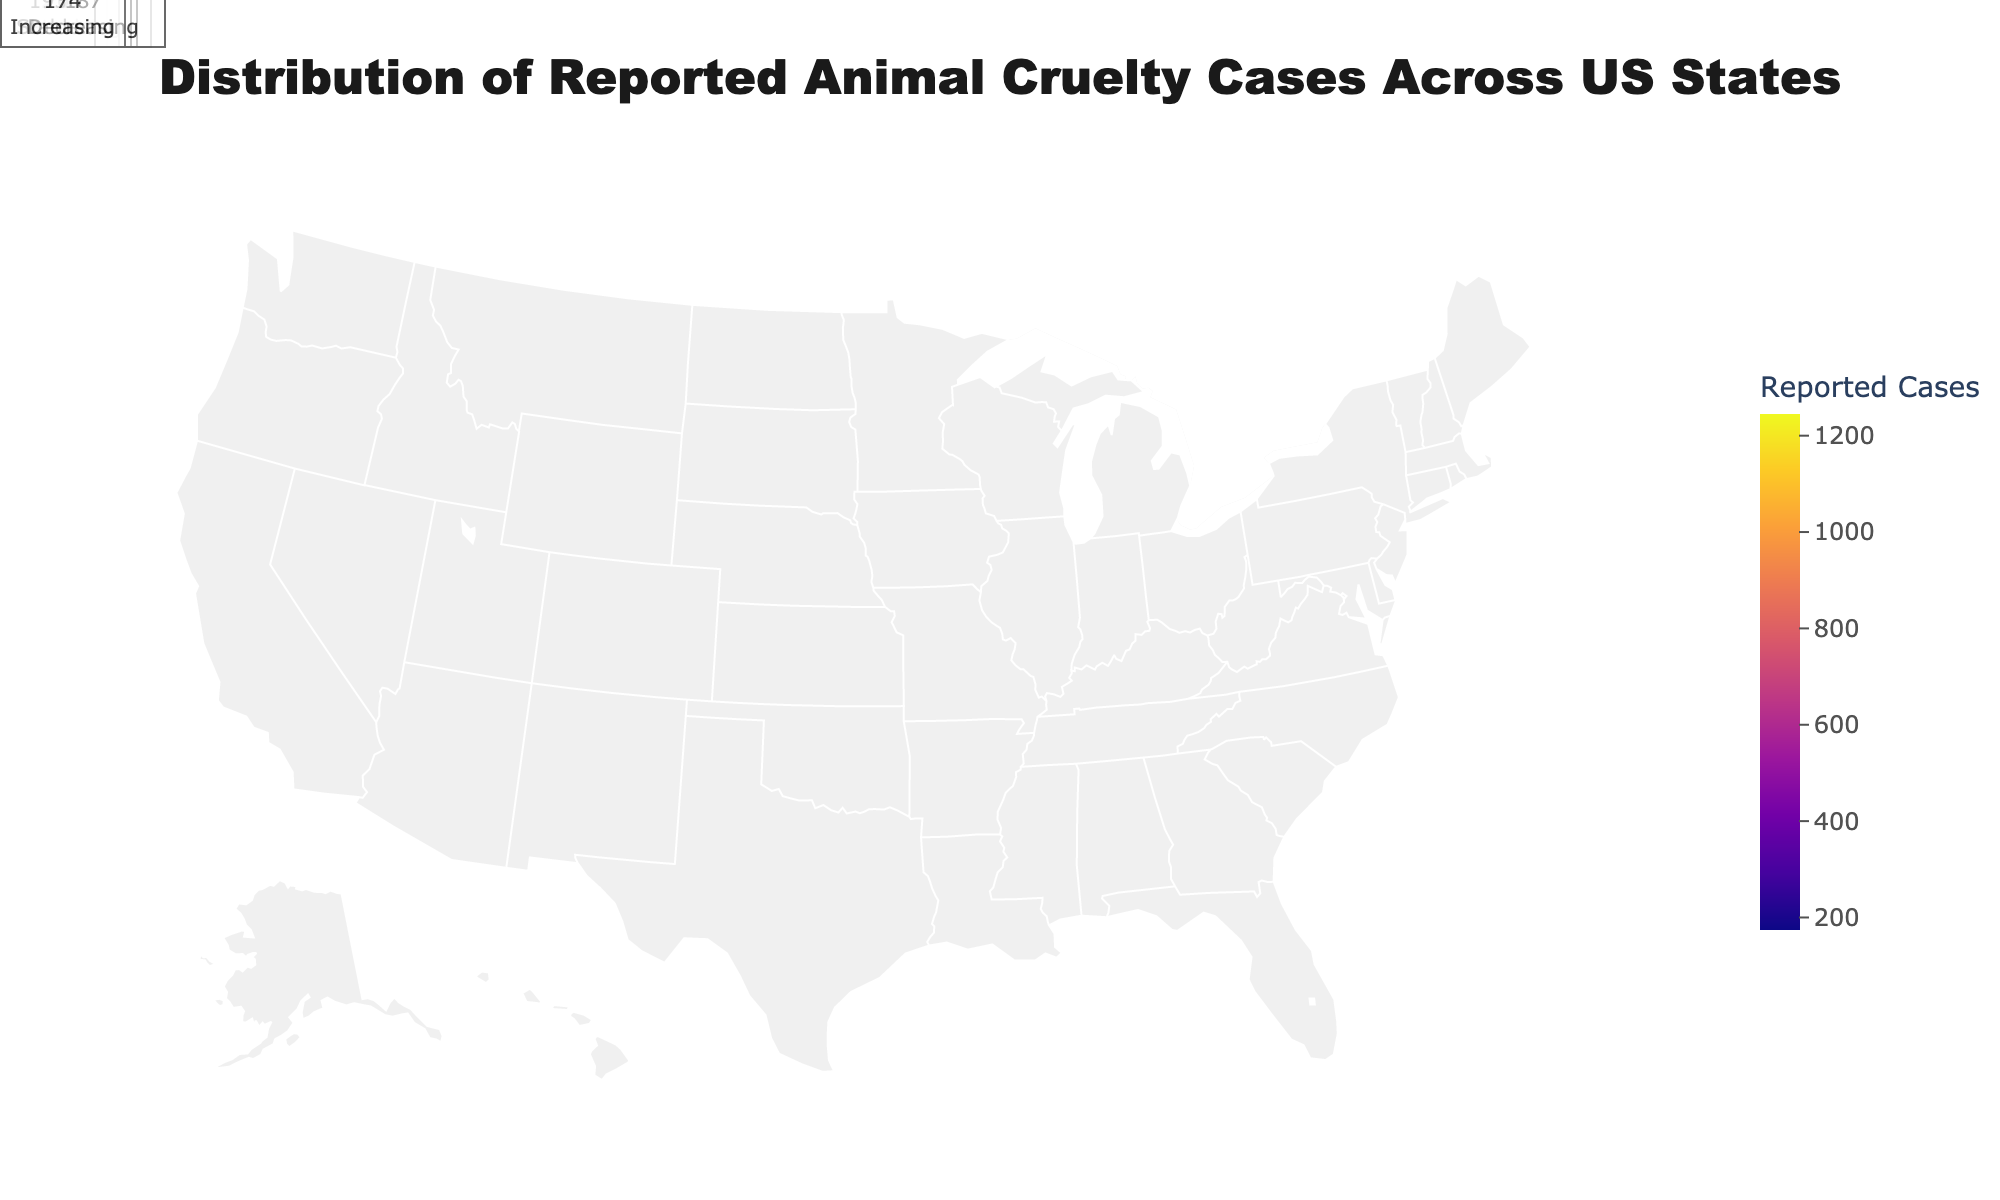Which state has the highest number of reported animal cruelty cases? According to the figure, the state with the highest number of reported animal cruelty cases is indicated by the darkest shade. Referring to the annotations, California has 1245 reported cases.
Answer: California What is the trend of reported animal cruelty cases in Pennsylvania? The figure includes trend information for each state. For Pennsylvania, the annotation indicates that the trend is "Increasing".
Answer: Increasing How many states have decreasing trends in reported animal cruelty cases? By examining the annotations for each state, we can identify the states with the "Decreasing" trend. They are New York, Michigan, Missouri, and Massachusetts, making a total of 4 states.
Answer: 4 Which state among Texas and Florida has more reported animal cruelty cases? According to the figure's color intensity and annotations, Texas has 982 reported cases, while Florida has 876 reported cases. Texas has more reported cases than Florida.
Answer: Texas What are the reported animal cruelty cases in states with a stable trend? From the figure, states with a "Stable" trend are Texas, Ohio, Illinois, North Carolina, Washington, Colorado, Wisconsin, and Indiana. Summing up their reported cases: 982 (TX) + 543 (OH) + 475 (IL) + 356 (NC) + 298 (WA) + 245 (CO) + 218 (WI) + 193 (IN) = 3310 cases.
Answer: 3310 Which states have less than 300 reported animal cruelty cases, and what are their trends? Referring to the annotations, the states with less than 300 cases are Arizona (276, Increasing), Colorado (245, Stable), Missouri (232, Decreasing), Wisconsin (218, Stable), Tennessee (205, Increasing), Indiana (193, Stable), Massachusetts (187, Decreasing), and Oregon (174, Increasing).
Answer: Arizona (Increasing), Colorado (Stable), Missouri (Decreasing), Wisconsin (Stable), Tennessee (Increasing), Indiana (Stable), Massachusetts (Decreasing), Oregon (Increasing) Compare the trends in reported animal cruelty cases in New York and Virginia. Which state has an increasing trend? According to the figure, New York has a "Decreasing" trend, whereas Virginia has an "Increasing" trend. Thus, Virginia has an increasing trend.
Answer: Virginia What is the average number of reported animal cruelty cases in states with an increasing trend? States with an increasing trend are California (1245), Florida (876), Pennsylvania (498), Georgia (389), Virginia (321), Arizona (276), Tennessee (205), and Oregon (174). Summing these: 1245 + 876 + 498 + 389 + 321 + 276 + 205 + 174 = 3984. The average is 3984/8 = 498 cases.
Answer: 498 Which state has the second-highest number of reported animal cruelty cases? Looking at the annotations, the state with the second-highest number of reported animal cruelty cases is Texas with 982 cases, following California.
Answer: Texas What is the total number of reported animal cruelty cases across all states in the figure? Summing the reported cases from all states: 1245 (CA) + 982 (TX) + 876 (FL) + 654 (NY) + 543 (OH) + 498 (PA) + 475 (IL) + 412 (MI) + 389 (GA) + 356 (NC) + 321 (VA) + 298 (WA) + 276 (AZ) + 245 (CO) + 232 (MO) + 218 (WI) + 205 (TN) + 193 (IN) + 187 (MA) + 174 (OR) = 9275.
Answer: 9275 